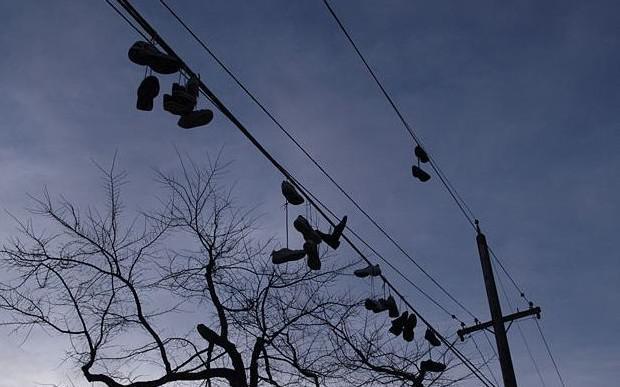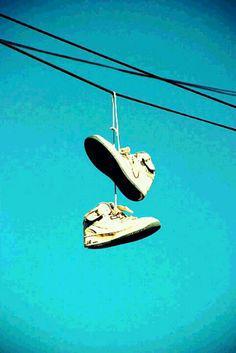The first image is the image on the left, the second image is the image on the right. Considering the images on both sides, is "There are more than 3 pairs of shoes hanging from an electric wire." valid? Answer yes or no. Yes. The first image is the image on the left, the second image is the image on the right. Evaluate the accuracy of this statement regarding the images: "One of the images shows multiple pairs of shoes hanging from a power line.". Is it true? Answer yes or no. Yes. 